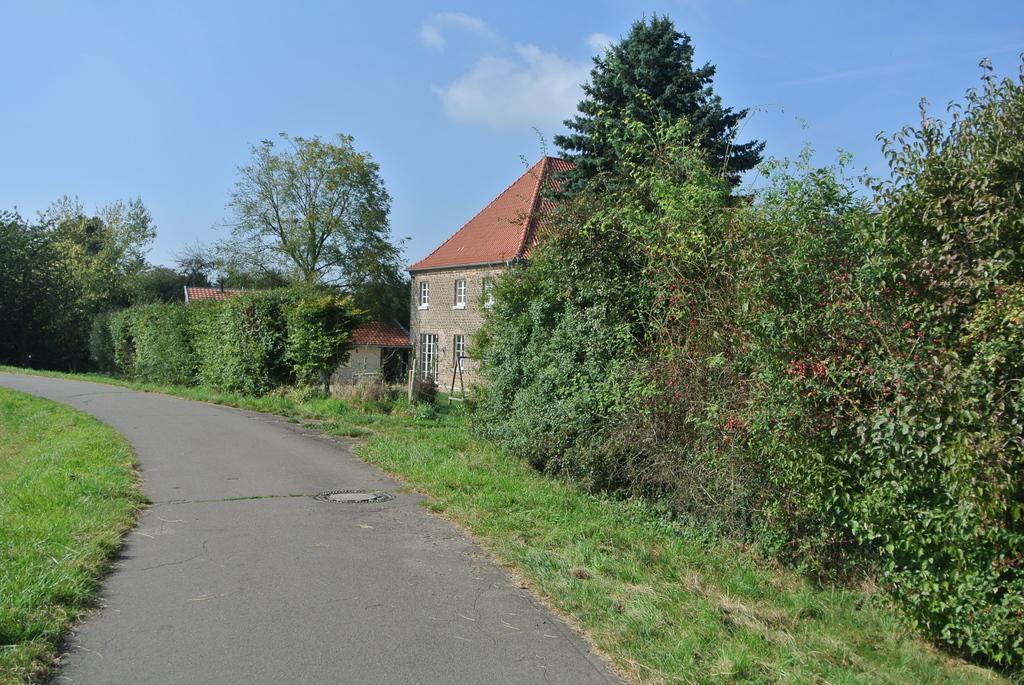Can you describe this image briefly? In the middle of the image we can see some plants, trees and houses. In the bottom left corner of the image we can see grass and road. At the top of the image we can see some clouds in the sky. 